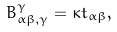<formula> <loc_0><loc_0><loc_500><loc_500>B _ { \alpha \beta , \gamma } ^ { \gamma } = \kappa t _ { \alpha \beta } ,</formula> 